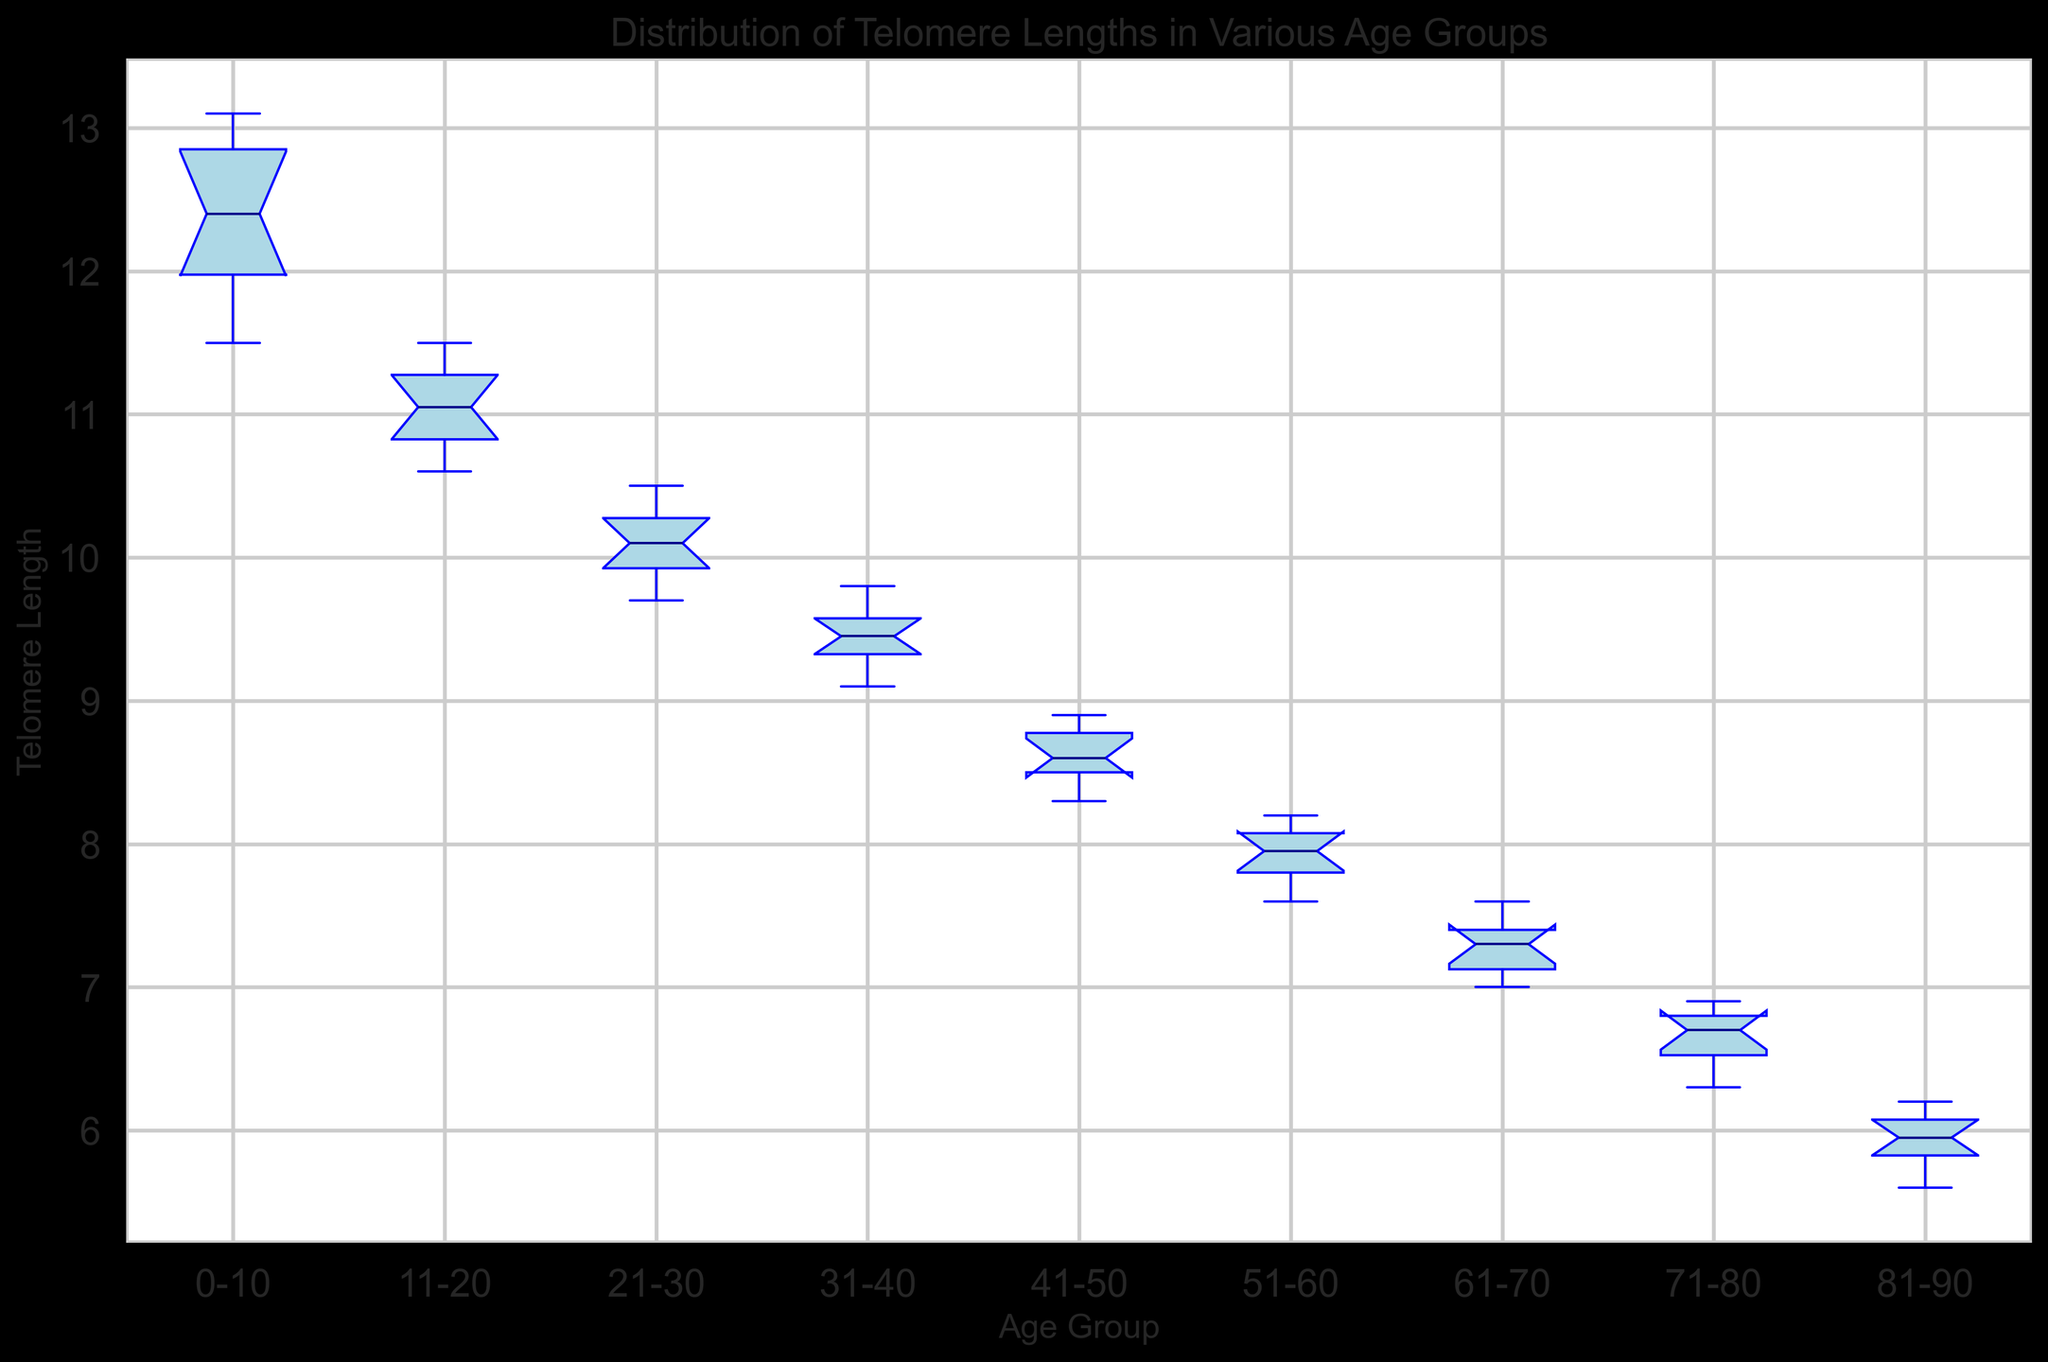What's the median value of the "31-40" age group? To find the median value from the "31-40" age group, look at the central line inside the box for that group. The median for "31-40" is around 9.5.
Answer: 9.5 Which age group has the widest range of telomere lengths? The range of telomere lengths is indicated by the length of the whiskers from the minimum to the maximum value outside the box. The "0-10" age group has the widest range, from around 11.5 to 13.1.
Answer: 0-10 What is the interquartile range (IQR) for the "0-10" age group? The IQR is the difference between the third quartile (Q3) and the first quartile (Q1). For "0-10," Q3 is around 12.85 and Q1 is around 11.8, so the IQR is 12.85 - 11.8 = 1.05.
Answer: 1.05 Which age group shows the smallest median telomere length? The minimum median value is indicated by the central line closest to the lower end of the y-axis. The "81-90" age group has the smallest median value, which is about 6.0.
Answer: 81-90 From which age group does telomere length start to show a noticeable decline? Noticeable decline is inferred by observing the box plot starting from which age group the median goes significantly downwards. The decline is noticeable starting from the "21-30" age group onwards.
Answer: 21-30 Is there any age group where the whiskers are the same length? The whiskers are the same length if the distance from the box to the whiskers' end points is equal on both sides. The "0-10" age group has almost equal whisker lengths.
Answer: 0-10 How does the median telomere length change as the age group increases from "11-20" to "21-30"? To see the change, compare the medians of these two groups. The median for "11-20" is around 11.0, and for "21-30" it is around 10.1, showing a decrease of 0.9.
Answer: Decreases by 0.9 Which age group shows the most compact distribution of telomere lengths? Compact distribution is indicated by the smallest box length. The "41-50" age group has the smallest box length, indicating the most compact distribution.
Answer: 41-50 Is the distribution of telomere lengths in "71-80" age group symmetric? Symmetry is indicated by the position of the median line within the box and the lengths of whiskers. The "71-80" age group box's median line is centered, but the whiskers show a slight asymmetry, indicating a slightly skewed distribution.
Answer: Slightly skewed 